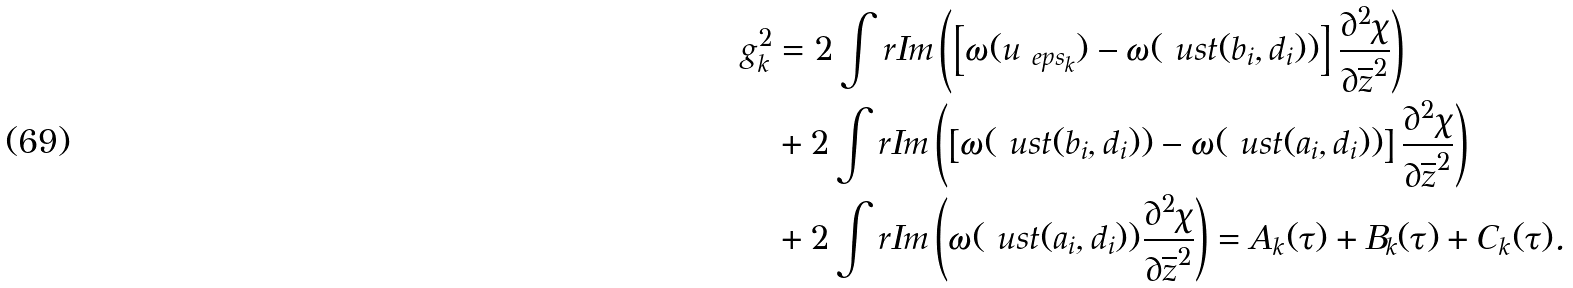<formula> <loc_0><loc_0><loc_500><loc_500>g _ { k } ^ { 2 } & = 2 \int r I m \left ( \left [ \omega ( u _ { \ e p s _ { k } } ) - \omega ( \ u s t ( b _ { i } , d _ { i } ) ) \right ] \frac { \partial ^ { 2 } \chi } { \partial \overline { z } ^ { 2 } } \right ) \\ & + 2 \int r I m \left ( \left [ \omega ( \ u s t ( b _ { i } , d _ { i } ) ) - \omega ( \ u s t ( a _ { i } , d _ { i } ) ) \right ] \frac { \partial ^ { 2 } \chi } { \partial \overline { z } ^ { 2 } } \right ) \\ & + 2 \int r I m \left ( \omega ( \ u s t ( a _ { i } , d _ { i } ) ) \frac { \partial ^ { 2 } \chi } { \partial \overline { z } ^ { 2 } } \right ) = A _ { k } ( \tau ) + B _ { k } ( \tau ) + C _ { k } ( \tau ) .</formula> 